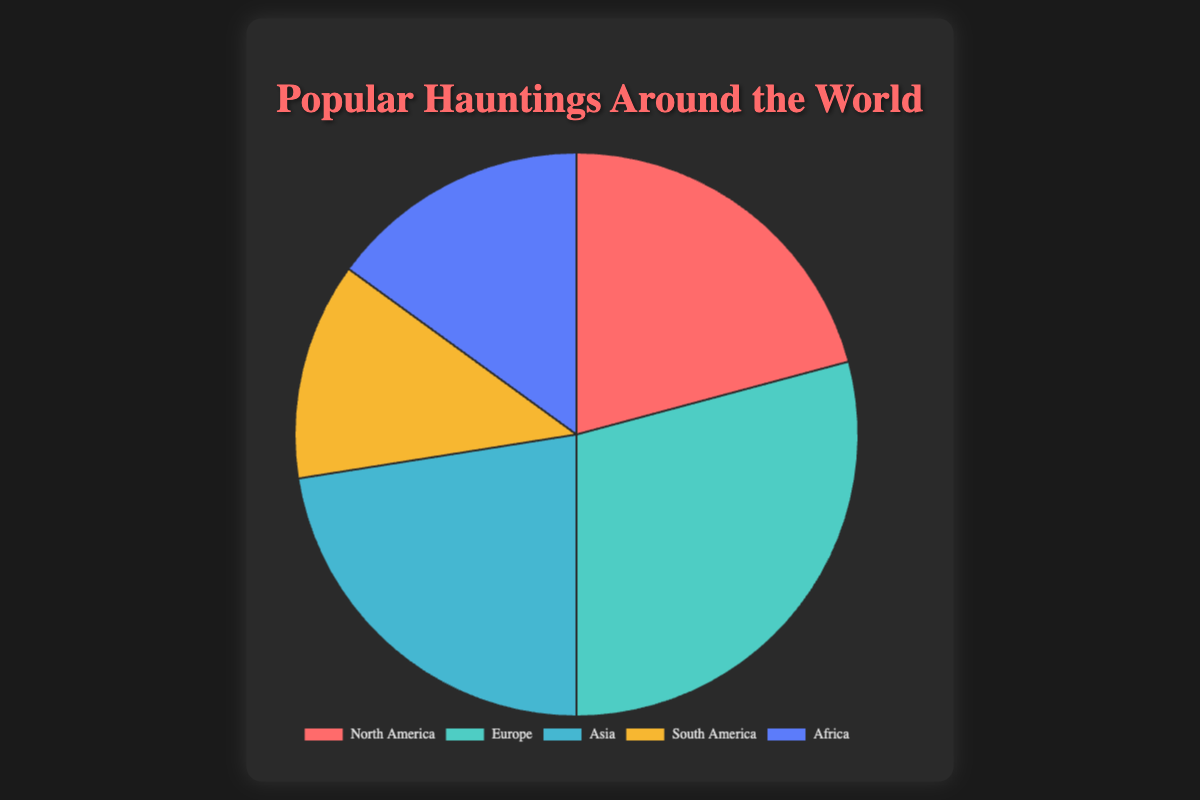Which continent has the highest number of hauntings? Observing the pie chart, the segment for Europe is the largest, indicating it has the highest number of hauntings with 35.
Answer: Europe Which continent has the lowest number of hauntings? By examining the pie chart, the South America segment is the smallest, signifying it has the lowest number of hauntings with 15.
Answer: South America How many more hauntings are there in Asia compared to Africa? First, identify the hauntings in Asia (27) and Africa (18). Then, subtract Africa's hauntings from Asia's: 27 - 18 = 9.
Answer: 9 What is the combined number of hauntings for North America and South America? Find the hauntings in North America (25) and South America (15). Then, add them together: 25 + 15 = 40.
Answer: 40 What is the average number of hauntings across all continents? Sum up the hauntings from all continents (25 + 35 + 27 + 15 + 18 = 120). Divide by the number of continents (5): 120 / 5 = 24.
Answer: 24 Which continents have more hauntings than North America? North America has 25 hauntings. By comparing, Europe (35) and Asia (27) have more hauntings.
Answer: Europe, Asia What percentage of the total hauntings occur in Europe? First, sum up the hauntings from all continents (120). Then, calculate the percentage of hauntings in Europe: (35 / 120) * 100 ≈ 29.17%.
Answer: ~29.17% What color represents the continent with the most hauntings? The pie chart shows Europe (the continent with the most hauntings) is represented by the color teal.
Answer: Teal (or light blue) How do hauntings in Africa compare to hauntings in South America? Africa has 18 hauntings while South America has 15. Therefore, Africa has more hauntings than South America.
Answer: Africa > South America What is the total number of hauntings outside of Europe? Europe has 35 hauntings, and the total hauntings is 120. Subtract Europe's hauntings from the total: 120 - 35 = 85.
Answer: 85 